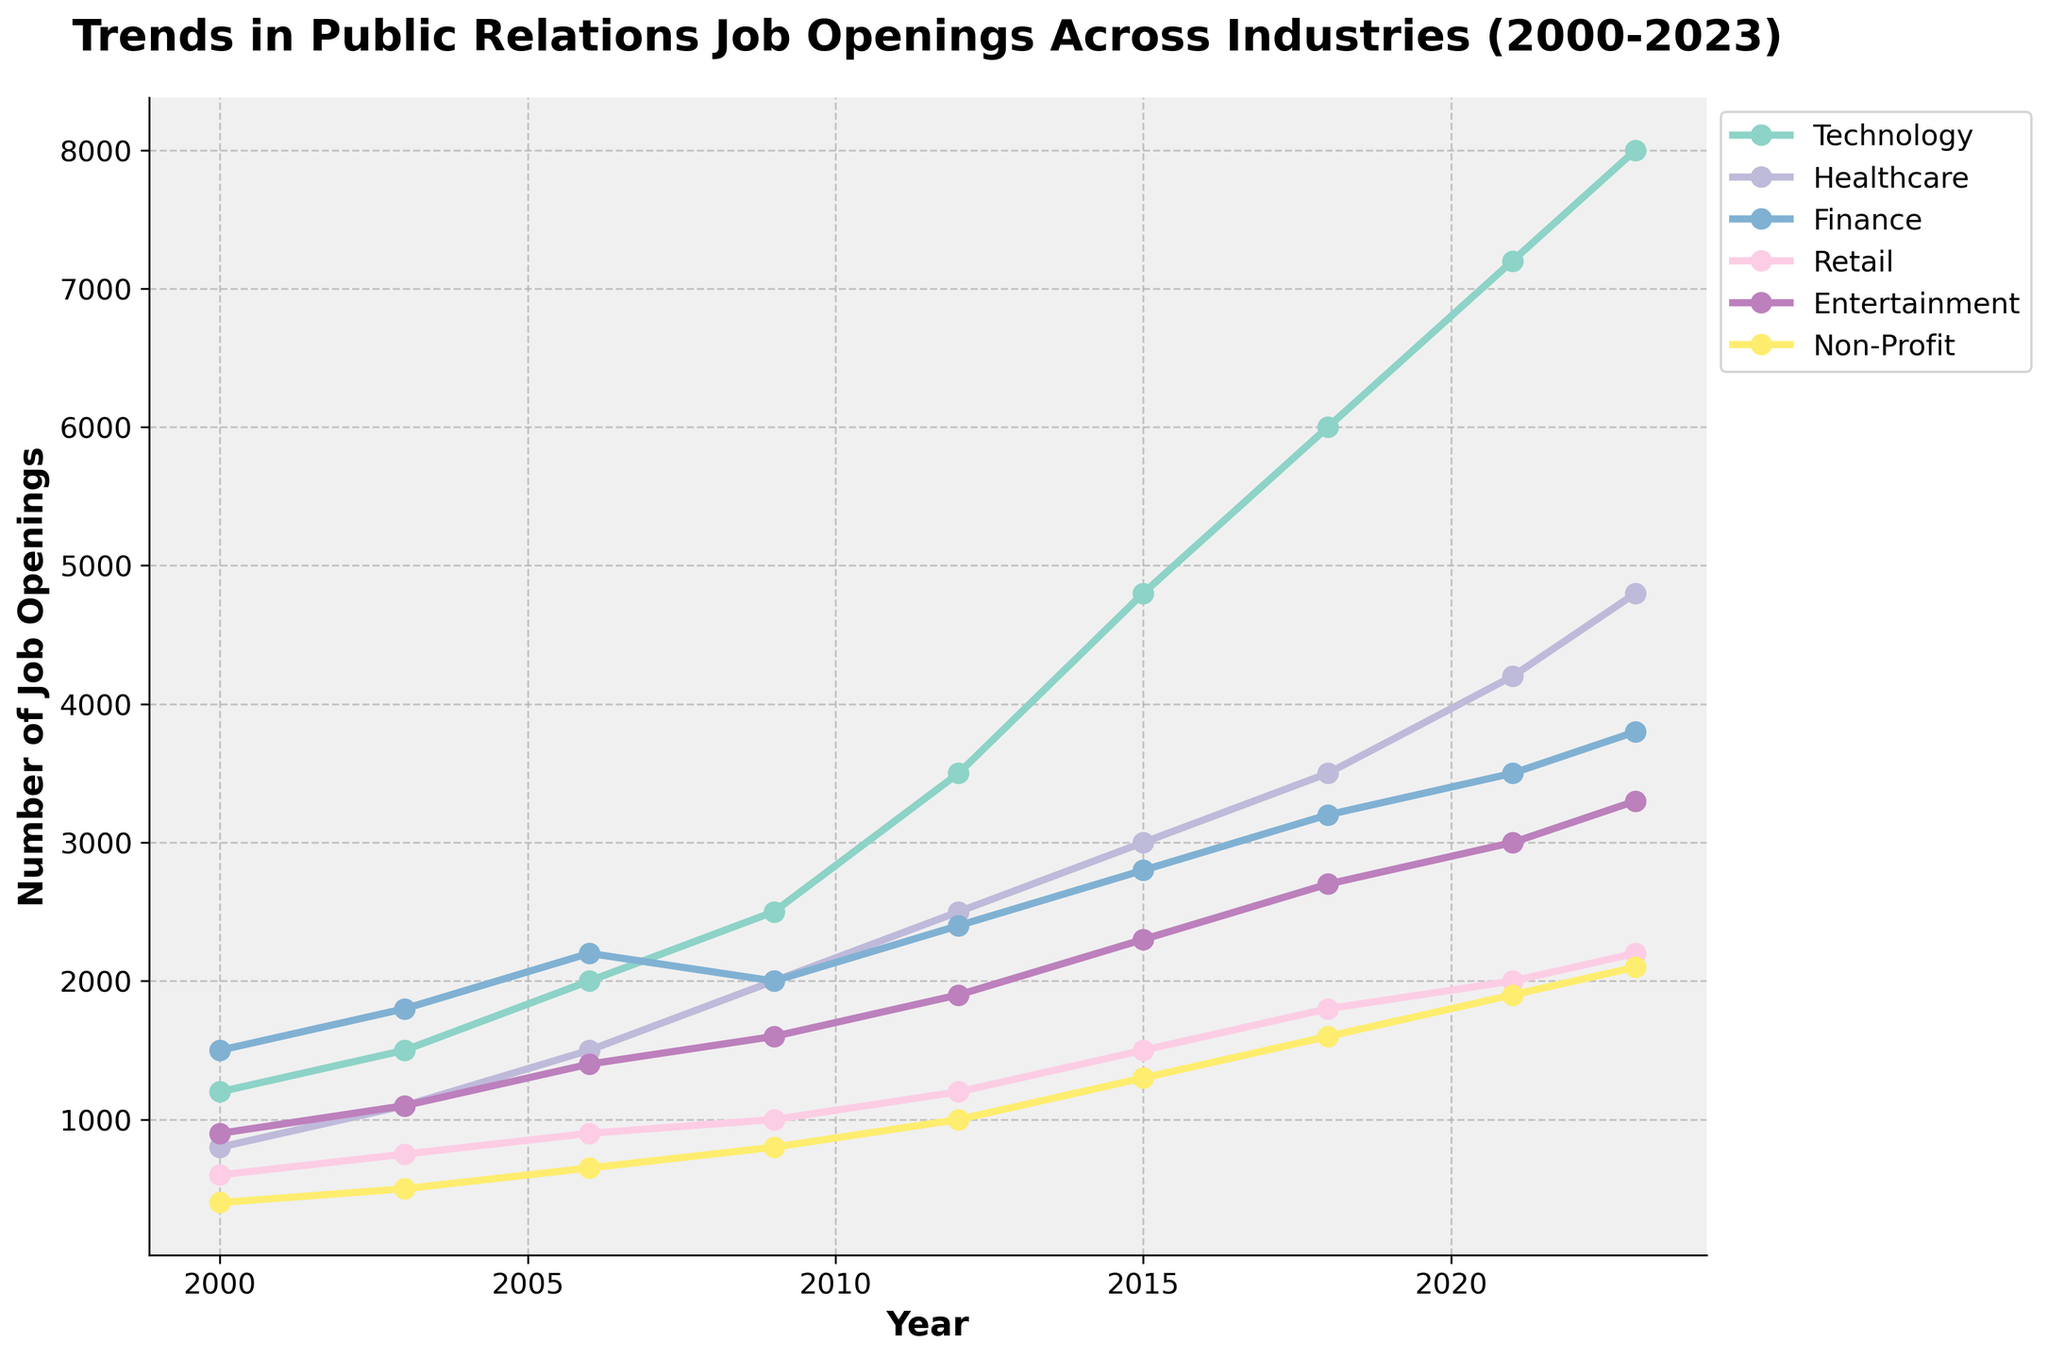How has the number of job openings in the Technology industry changed from 2000 to 2023? To answer this question, look at the line graph for the Technology industry. In 2000, the number of job openings in Technology was 1200. By 2023, this number increased to 8000.
Answer: Increased by 6800 What is the difference in the number of job openings between the Healthcare and Finance industries in 2023? Compare the points for Healthcare and Finance in 2023 on the graph. Healthcare has 4800 job openings, and Finance has 3800 job openings. The difference is 4800 - 3800.
Answer: 1000 Which industry had the highest number of job openings in 2021? To find this, check the 2021 data points and look for the highest point among all industries. The highest point in 2021 is for the Technology industry with 7200 job openings.
Answer: Technology In which year did the Non-Profit industry first reach 1000 job openings? Look at the Non-Profit industry line and find the year when it first reaches 1000 job openings. It reached 1000 job openings in 2012.
Answer: 2012 What is the average number of job openings in the Retail industry from 2000 to 2023? To find the average, add the job openings in Retail for all given years (600 + 750 + 900 + 1000 + 1200 + 1500 + 1800 + 2000 + 2200), then divide by the number of years (9). So (600+750+900+1000+1200+1500+1800+2000+2200) / 9 = 1217.
Answer: 1217 Which industry showed the most consistent increase in job openings over the period 2000 to 2023? To determine this, look at the slopes of the lines for each industry. The Technology industry shows a consistent and steep increase without major drops or plateaus.
Answer: Technology How did the number of job openings in the Entertainment industry change from 2009 to 2012? Check the Entertainment industry line between 2009 and 2012. In 2009, there were 1600 job openings, and by 2012, there were 1900. The increase is 1900 - 1600.
Answer: Increased by 300 Which two industries had the closest number of job openings in 2003? Look at the data points for 2003. Healthcare had 1100 and Retail had 750 job openings. The difference between them is the smallest among all industries in that year.
Answer: Healthcare and Finance By how much did job openings in the Non-Profit sector increase from 2006 to 2023? Look at the data points for Non-Profit in 2006 and 2023. In 2006, there were 650 job openings, and in 2023, there were 2100. The increase is 2100 - 650.
Answer: Increased by 1450 